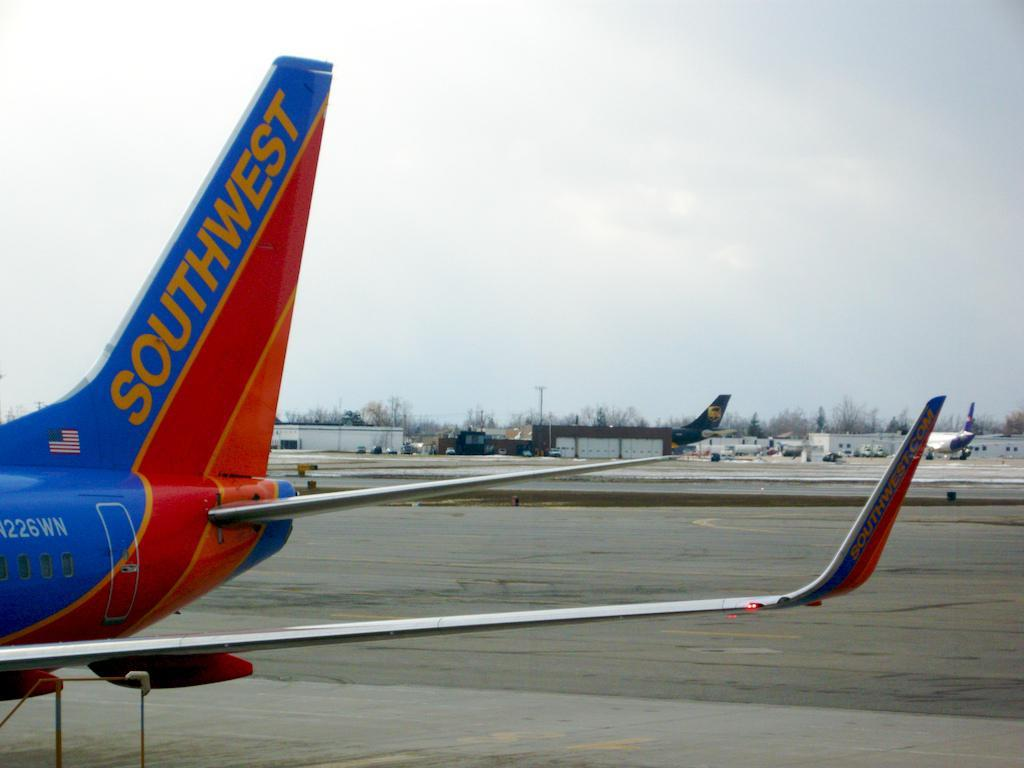Provide a one-sentence caption for the provided image. a southwest tail end of an airplane on the ground. 